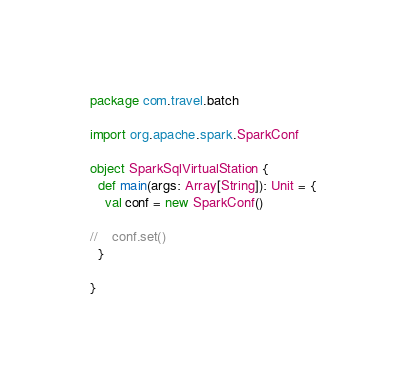Convert code to text. <code><loc_0><loc_0><loc_500><loc_500><_Scala_>package com.travel.batch

import org.apache.spark.SparkConf

object SparkSqlVirtualStation {
  def main(args: Array[String]): Unit = {
    val conf = new SparkConf()

//    conf.set()
  }

}
</code> 